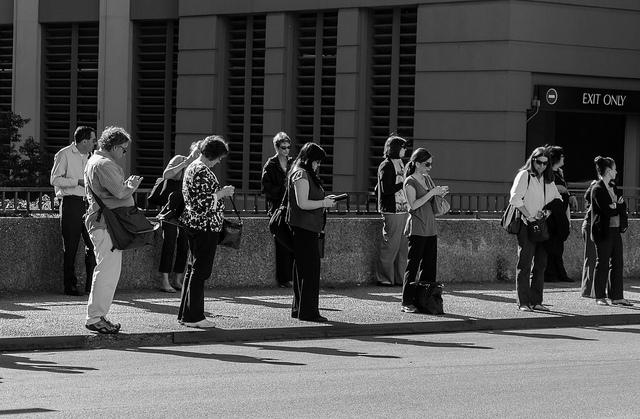What are the people likely doing? waiting 